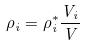Convert formula to latex. <formula><loc_0><loc_0><loc_500><loc_500>\rho _ { i } = \rho _ { i } ^ { * } \frac { V _ { i } } { V }</formula> 